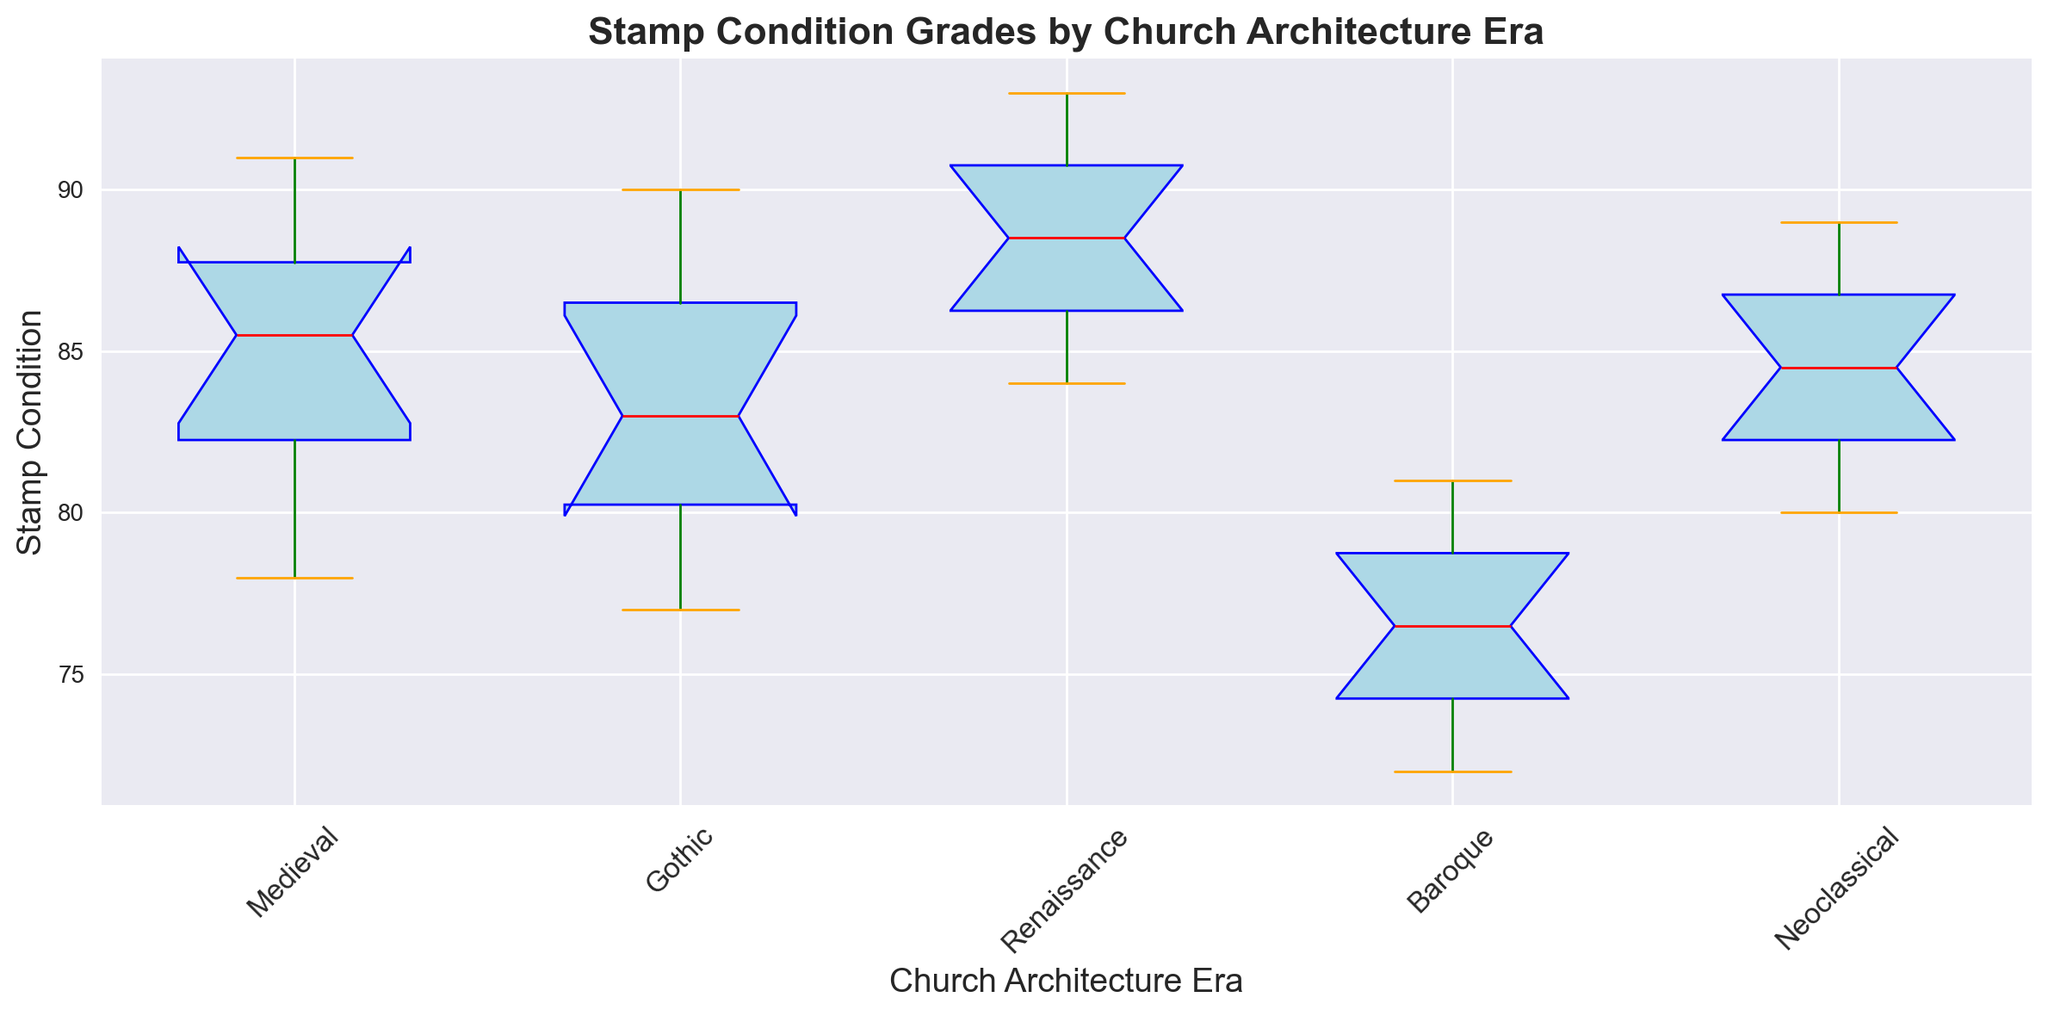What is the median stamp condition for the Gothic era? Locate the box corresponding to the Gothic era, then find the central line inside it, which represents the median value of the stamp conditions for that era.
Answer: 82 Which church architecture era shows the highest variability in stamp condition grades? Compare the length of the whiskers (lines extending from the top and bottom of the boxes) across all eras. The era with the longest whiskers will have the greatest variability.
Answer: Baroque How do the median stamp conditions of the Medieval and Renaissance eras compare? Locate the median lines in the Medieval and Renaissance era boxes and compare their heights.
Answer: The median of the Renaissance is higher than the Medieval What is the range of stamp condition grades for the Neoclassical era? The range is determined by the difference between the maximum and minimum values shown by the top and bottom whiskers of the Neoclassical era box.
Answer: 9 Which era has the lowest minimum stamp condition? Look at the bottom whiskers of all the boxes and identify the shortest one, corresponding to the lowest minimum condition.
Answer: Baroque How does the interquartile range (IQR) of the Renaissance era compare to the Gothic era? The IQR is the difference between the top and bottom of the box. Measure this difference for both the Renaissance and Gothic eras and compare.
Answer: The IQR of Renaissance is similar to or slightly larger than Gothic Which era's box is colored in light blue with green whiskers and orange caps? Identify the visual characteristics of the boxes such as color and shape. The boxes for all eras are light blue with green whiskers and orange caps, so they all have these visual traits.
Answer: All eras What percentage of Baroque era stamps are below the median value of Gothic era stamps? Count the number of Baroque era data points below the Gothic median line (which is 82). There are five such points out of a total of ten points in the Baroque dataset. So, calculate (5/10)*100.
Answer: 50% 